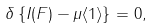Convert formula to latex. <formula><loc_0><loc_0><loc_500><loc_500>\delta \left \{ I ( F ) - \mu \langle 1 \rangle \right \} = 0 ,</formula> 